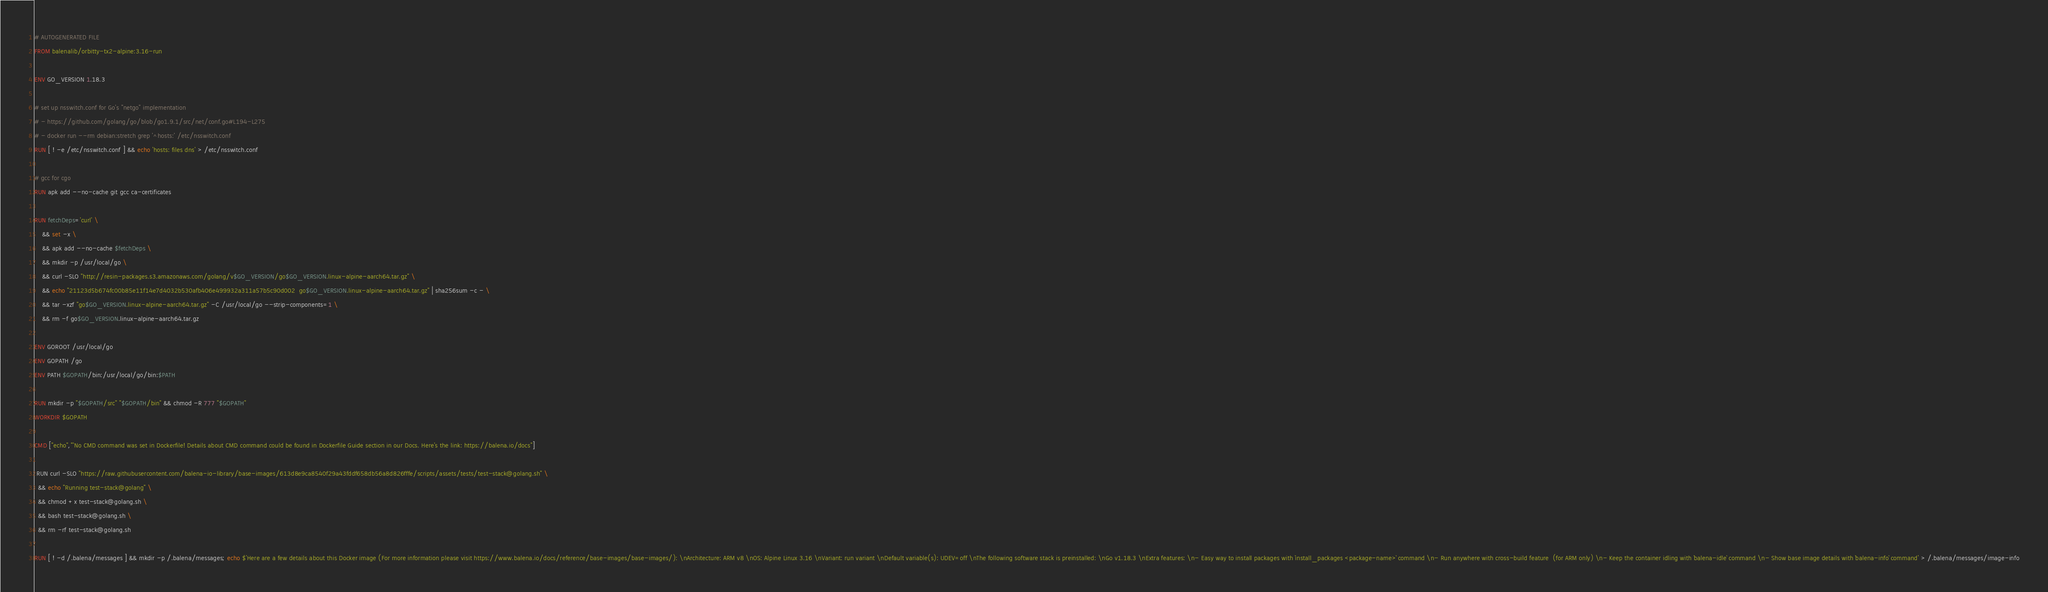Convert code to text. <code><loc_0><loc_0><loc_500><loc_500><_Dockerfile_># AUTOGENERATED FILE
FROM balenalib/orbitty-tx2-alpine:3.16-run

ENV GO_VERSION 1.18.3

# set up nsswitch.conf for Go's "netgo" implementation
# - https://github.com/golang/go/blob/go1.9.1/src/net/conf.go#L194-L275
# - docker run --rm debian:stretch grep '^hosts:' /etc/nsswitch.conf
RUN [ ! -e /etc/nsswitch.conf ] && echo 'hosts: files dns' > /etc/nsswitch.conf

# gcc for cgo
RUN apk add --no-cache git gcc ca-certificates

RUN fetchDeps='curl' \
	&& set -x \
	&& apk add --no-cache $fetchDeps \
	&& mkdir -p /usr/local/go \
	&& curl -SLO "http://resin-packages.s3.amazonaws.com/golang/v$GO_VERSION/go$GO_VERSION.linux-alpine-aarch64.tar.gz" \
	&& echo "21123d5b674fc00b85e11f14e7d4032b530afb406e499932a311a57b5c90d002  go$GO_VERSION.linux-alpine-aarch64.tar.gz" | sha256sum -c - \
	&& tar -xzf "go$GO_VERSION.linux-alpine-aarch64.tar.gz" -C /usr/local/go --strip-components=1 \
	&& rm -f go$GO_VERSION.linux-alpine-aarch64.tar.gz

ENV GOROOT /usr/local/go
ENV GOPATH /go
ENV PATH $GOPATH/bin:/usr/local/go/bin:$PATH

RUN mkdir -p "$GOPATH/src" "$GOPATH/bin" && chmod -R 777 "$GOPATH"
WORKDIR $GOPATH

CMD ["echo","'No CMD command was set in Dockerfile! Details about CMD command could be found in Dockerfile Guide section in our Docs. Here's the link: https://balena.io/docs"]

 RUN curl -SLO "https://raw.githubusercontent.com/balena-io-library/base-images/613d8e9ca8540f29a43fddf658db56a8d826fffe/scripts/assets/tests/test-stack@golang.sh" \
  && echo "Running test-stack@golang" \
  && chmod +x test-stack@golang.sh \
  && bash test-stack@golang.sh \
  && rm -rf test-stack@golang.sh 

RUN [ ! -d /.balena/messages ] && mkdir -p /.balena/messages; echo $'Here are a few details about this Docker image (For more information please visit https://www.balena.io/docs/reference/base-images/base-images/): \nArchitecture: ARM v8 \nOS: Alpine Linux 3.16 \nVariant: run variant \nDefault variable(s): UDEV=off \nThe following software stack is preinstalled: \nGo v1.18.3 \nExtra features: \n- Easy way to install packages with `install_packages <package-name>` command \n- Run anywhere with cross-build feature  (for ARM only) \n- Keep the container idling with `balena-idle` command \n- Show base image details with `balena-info` command' > /.balena/messages/image-info</code> 